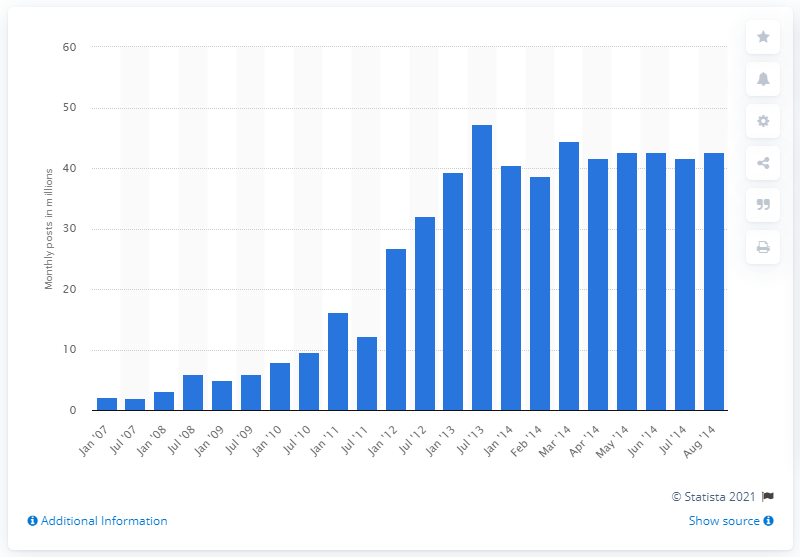Give some essential details in this illustration. In August 2014, WordPress users posted a total of 42.66... posts. 